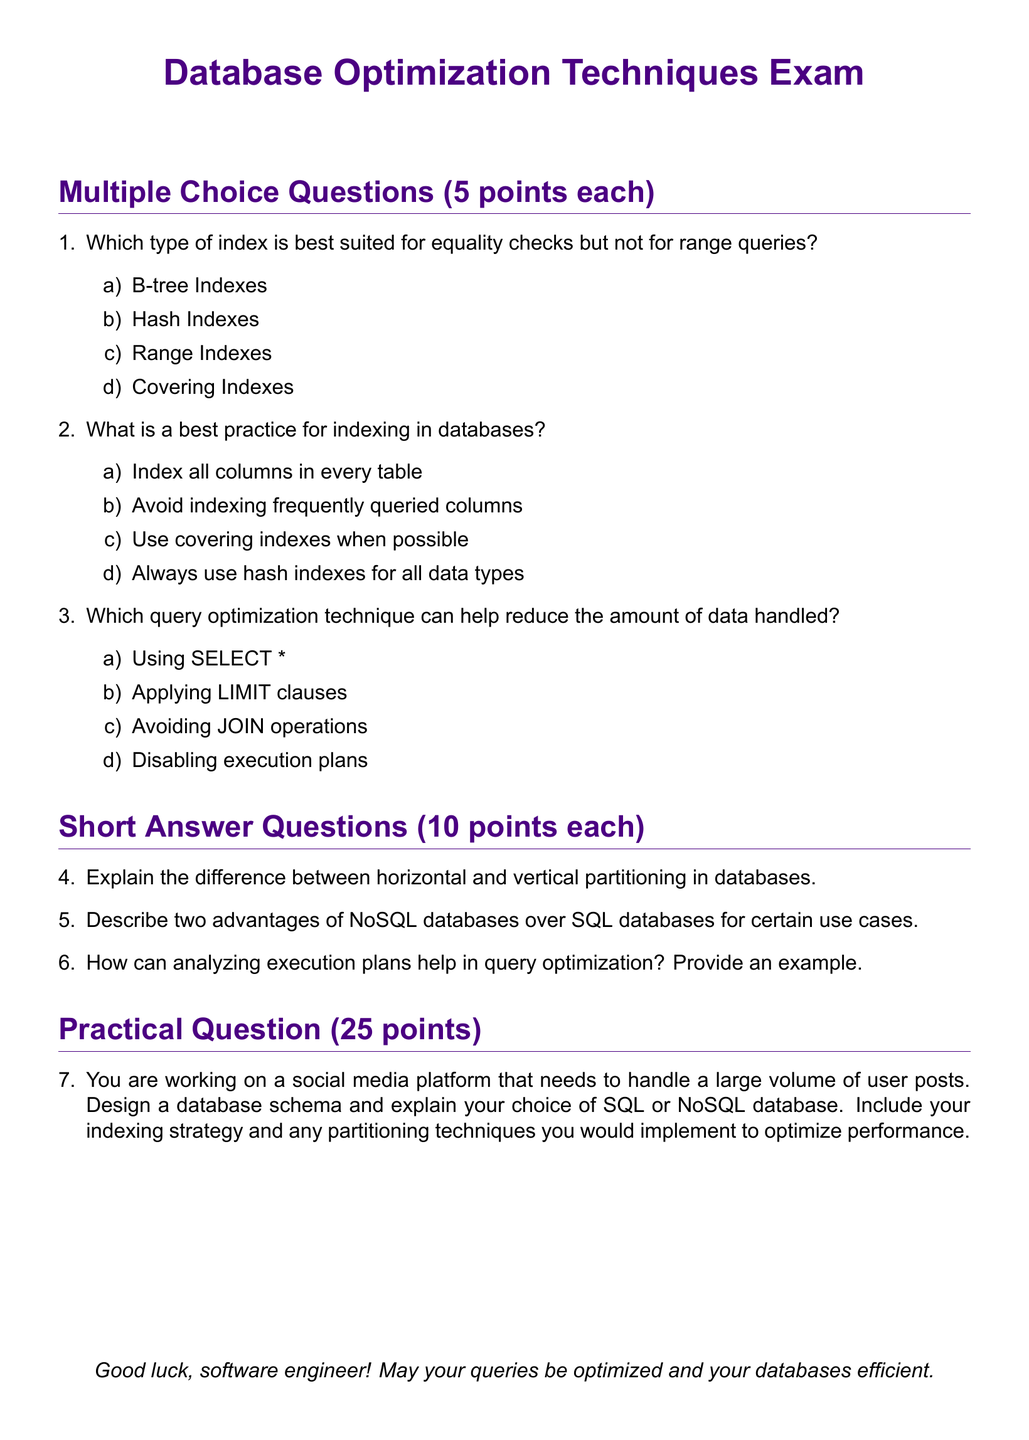What is the title of the exam? The title of the exam is presented at the beginning of the document in a large font.
Answer: Database Optimization Techniques Exam How many points is each multiple choice question worth? The document states that each multiple choice question is worth 5 points.
Answer: 5 points What is the maximum score for the practical question? The practical question is assigned a score indicated in the document.
Answer: 25 points What are the two types of partitioning mentioned in the short answer questions? The document references horizontal and vertical partitioning as the two types.
Answer: horizontal and vertical Which indexing strategy is recommended in the best practices section? The document suggests a specific indexing strategy that's not about indexing all columns.
Answer: Use covering indexes when possible What can help reduce the amount of data handled in query optimization? The document identifies a specific method among the options for reducing data.
Answer: Applying LIMIT clauses What color is used for the section headers? The document indicates a specific color used for headers in the formatting section.
Answer: headercolor Which operation is discouraged for optimizing queries according to the multiple-choice questions? One of the options in the multiple-choice questions suggests avoiding a specific database operation.
Answer: Using SELECT * 